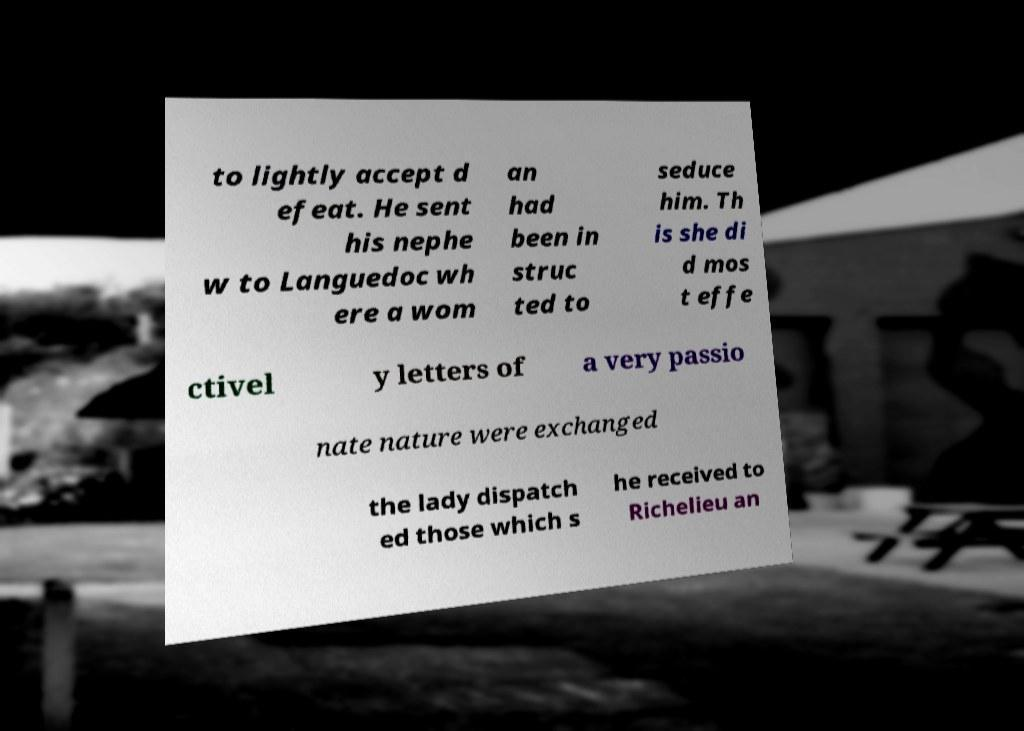Please read and relay the text visible in this image. What does it say? to lightly accept d efeat. He sent his nephe w to Languedoc wh ere a wom an had been in struc ted to seduce him. Th is she di d mos t effe ctivel y letters of a very passio nate nature were exchanged the lady dispatch ed those which s he received to Richelieu an 